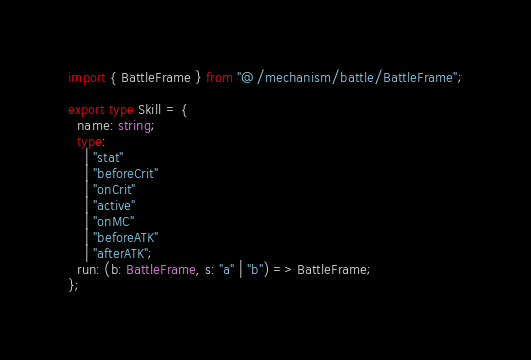Convert code to text. <code><loc_0><loc_0><loc_500><loc_500><_TypeScript_>import { BattleFrame } from "@/mechanism/battle/BattleFrame";

export type Skill = {
  name: string;
  type:
    | "stat"
    | "beforeCrit"
    | "onCrit"
    | "active"
    | "onMC"
    | "beforeATK"
    | "afterATK";
  run: (b: BattleFrame, s: "a" | "b") => BattleFrame;
};
</code> 